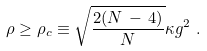Convert formula to latex. <formula><loc_0><loc_0><loc_500><loc_500>\rho \geq \rho _ { c } \equiv \sqrt { \frac { 2 ( N \, - \, 4 ) } { N } } \kappa g ^ { 2 } \ .</formula> 